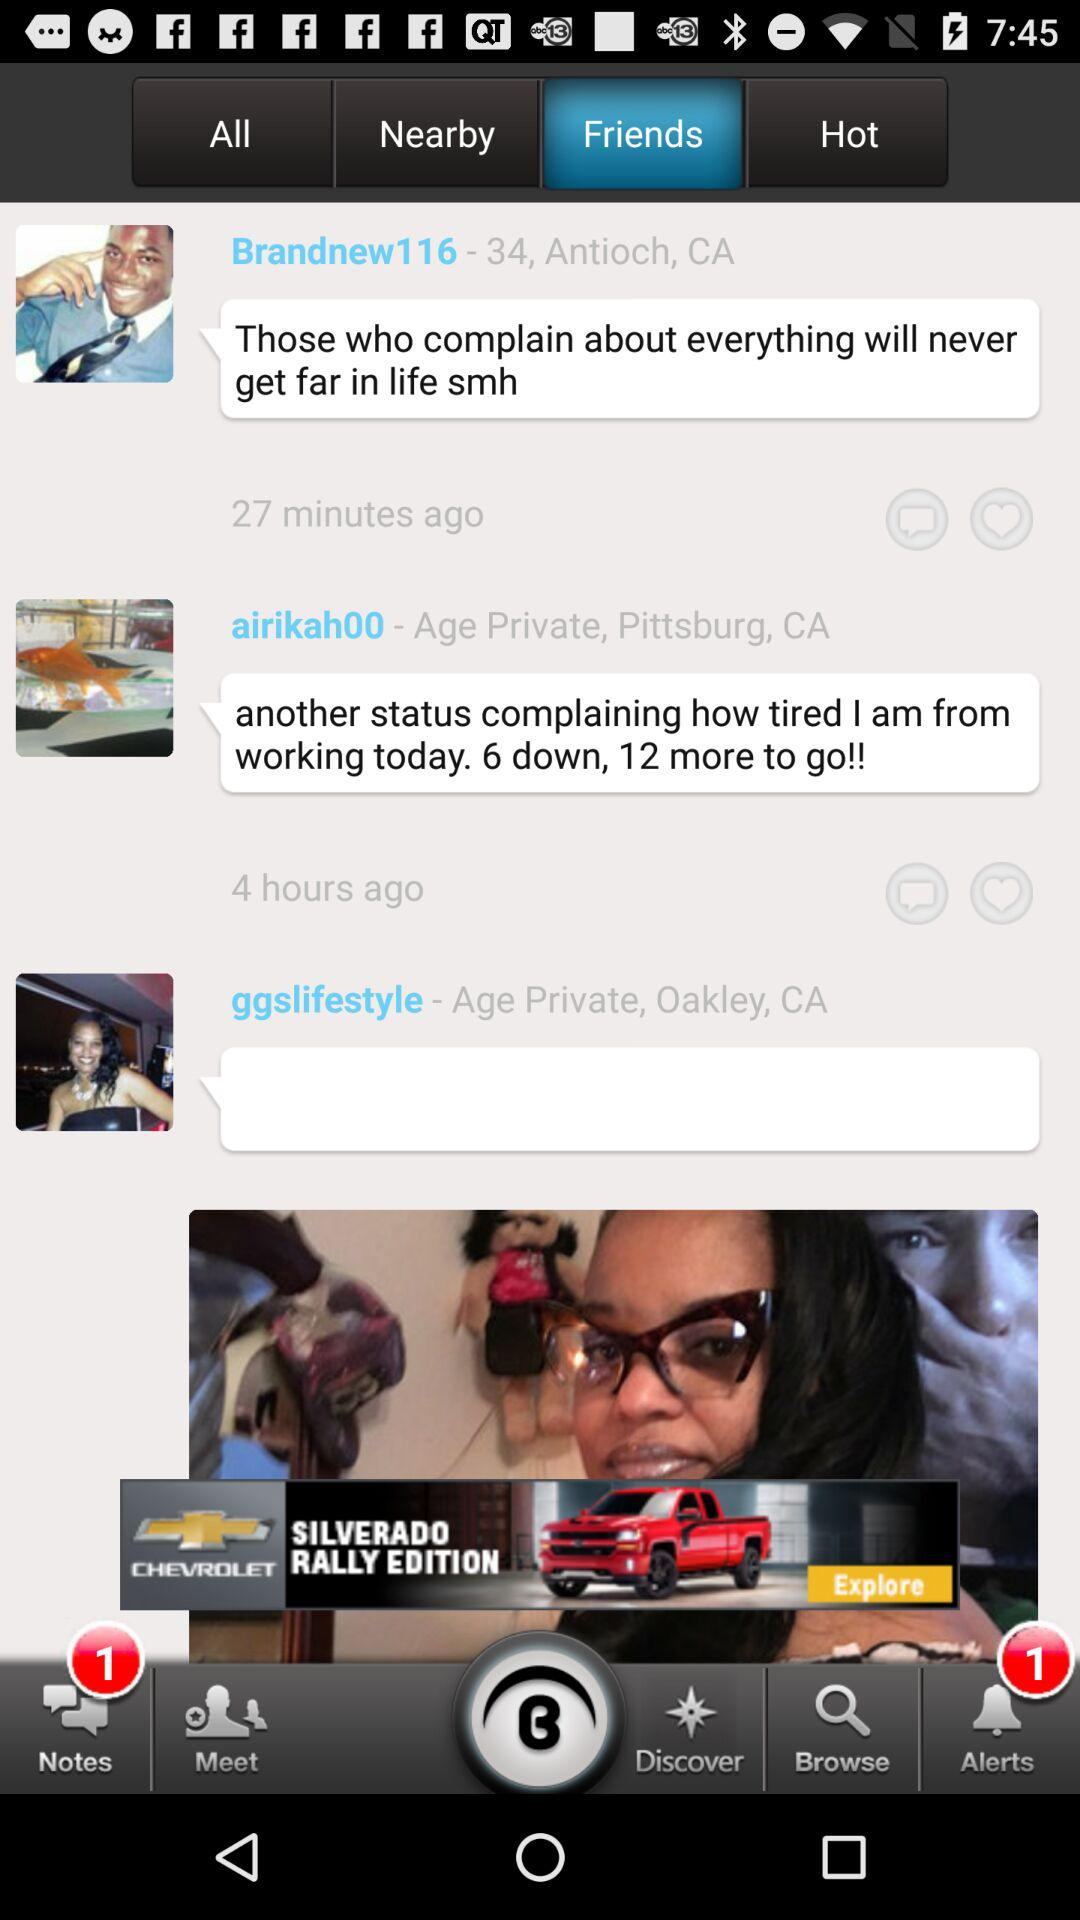How many notes are unread? There is 1 unread note. 